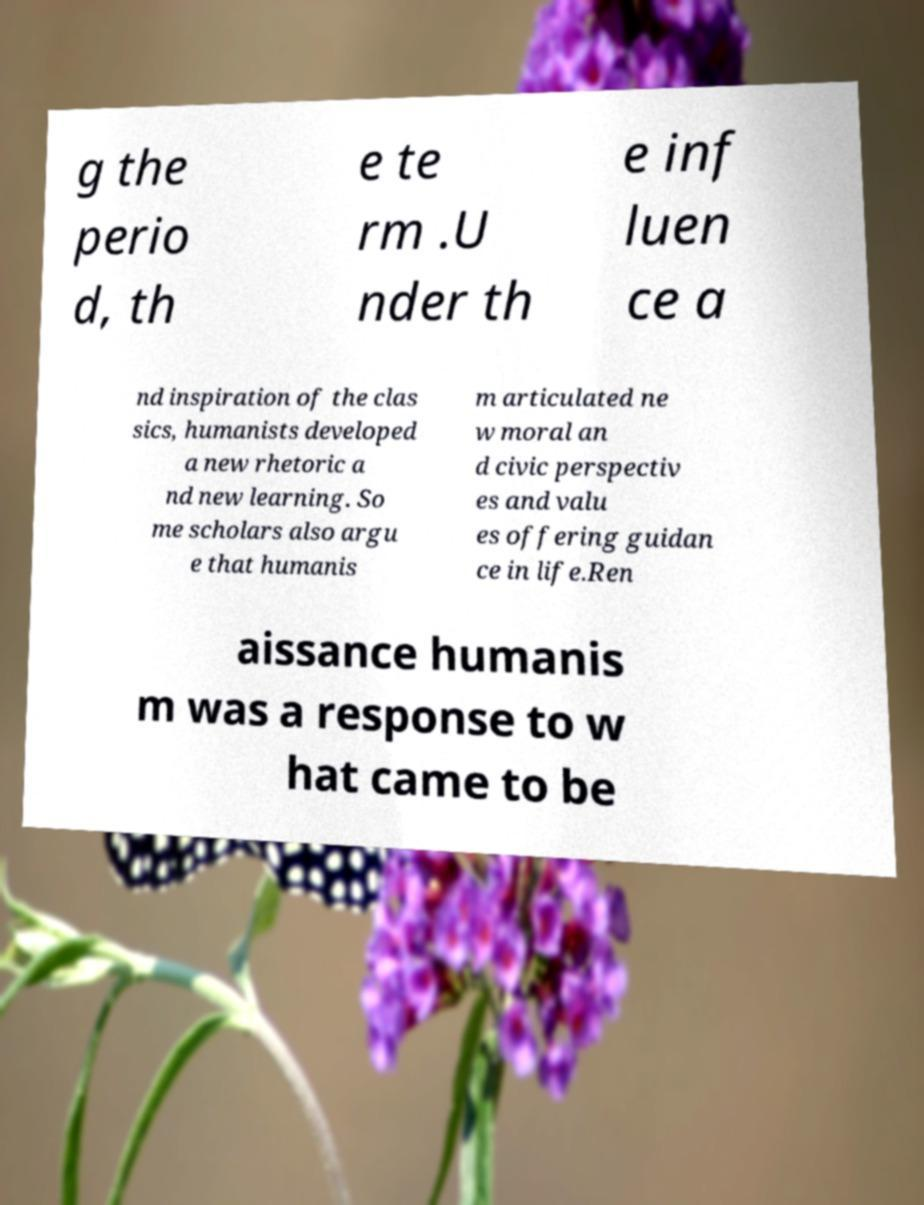Could you extract and type out the text from this image? g the perio d, th e te rm .U nder th e inf luen ce a nd inspiration of the clas sics, humanists developed a new rhetoric a nd new learning. So me scholars also argu e that humanis m articulated ne w moral an d civic perspectiv es and valu es offering guidan ce in life.Ren aissance humanis m was a response to w hat came to be 